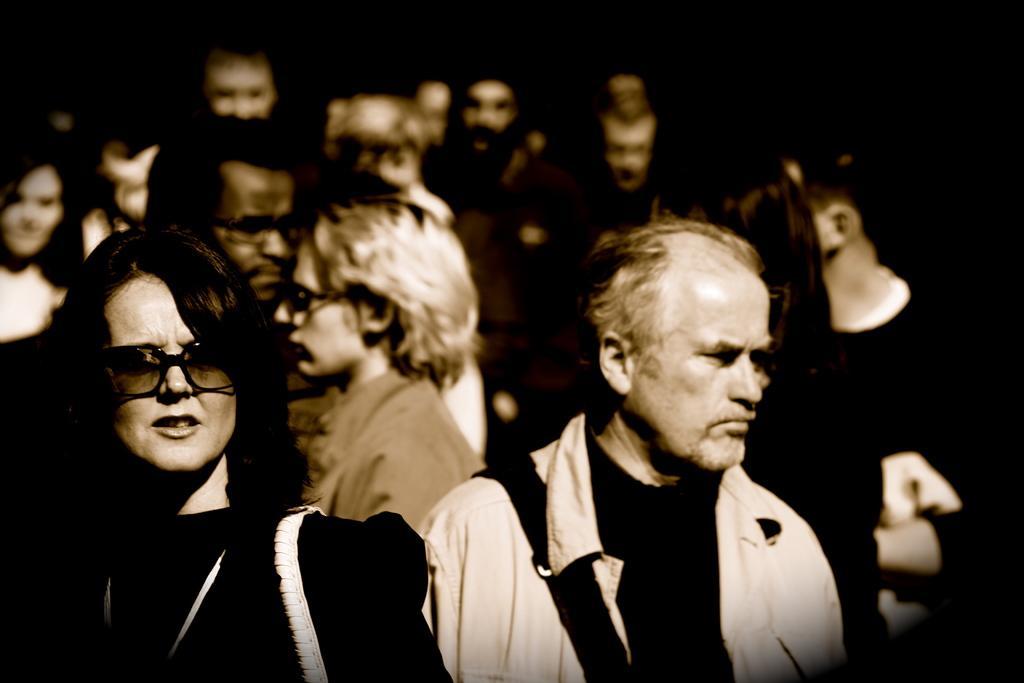Can you describe this image briefly? In this picture there are group of people. At the back there is a black background. 